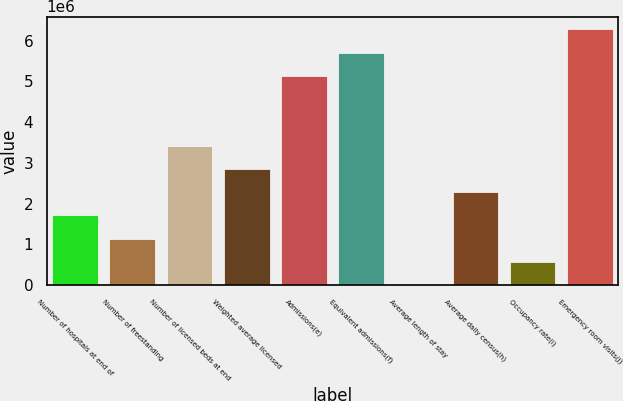Convert chart to OTSL. <chart><loc_0><loc_0><loc_500><loc_500><bar_chart><fcel>Number of hospitals at end of<fcel>Number of freestanding<fcel>Number of licensed beds at end<fcel>Weighted average licensed<fcel>Admissions(e)<fcel>Equivalent admissions(f)<fcel>Average length of stay<fcel>Average daily census(h)<fcel>Occupancy rate(i)<fcel>Emergency room visits(j)<nl><fcel>1.71186e+06<fcel>1.14124e+06<fcel>3.42372e+06<fcel>2.8531e+06<fcel>5.13558e+06<fcel>5.7062e+06<fcel>4.8<fcel>2.28248e+06<fcel>570624<fcel>6.27682e+06<nl></chart> 